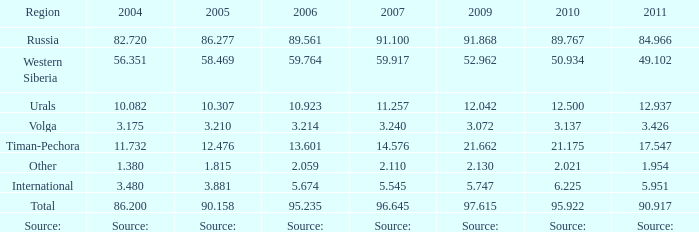What was the 2004 lukoil oil generation when in 2011 oil production reached 9 86.2. 